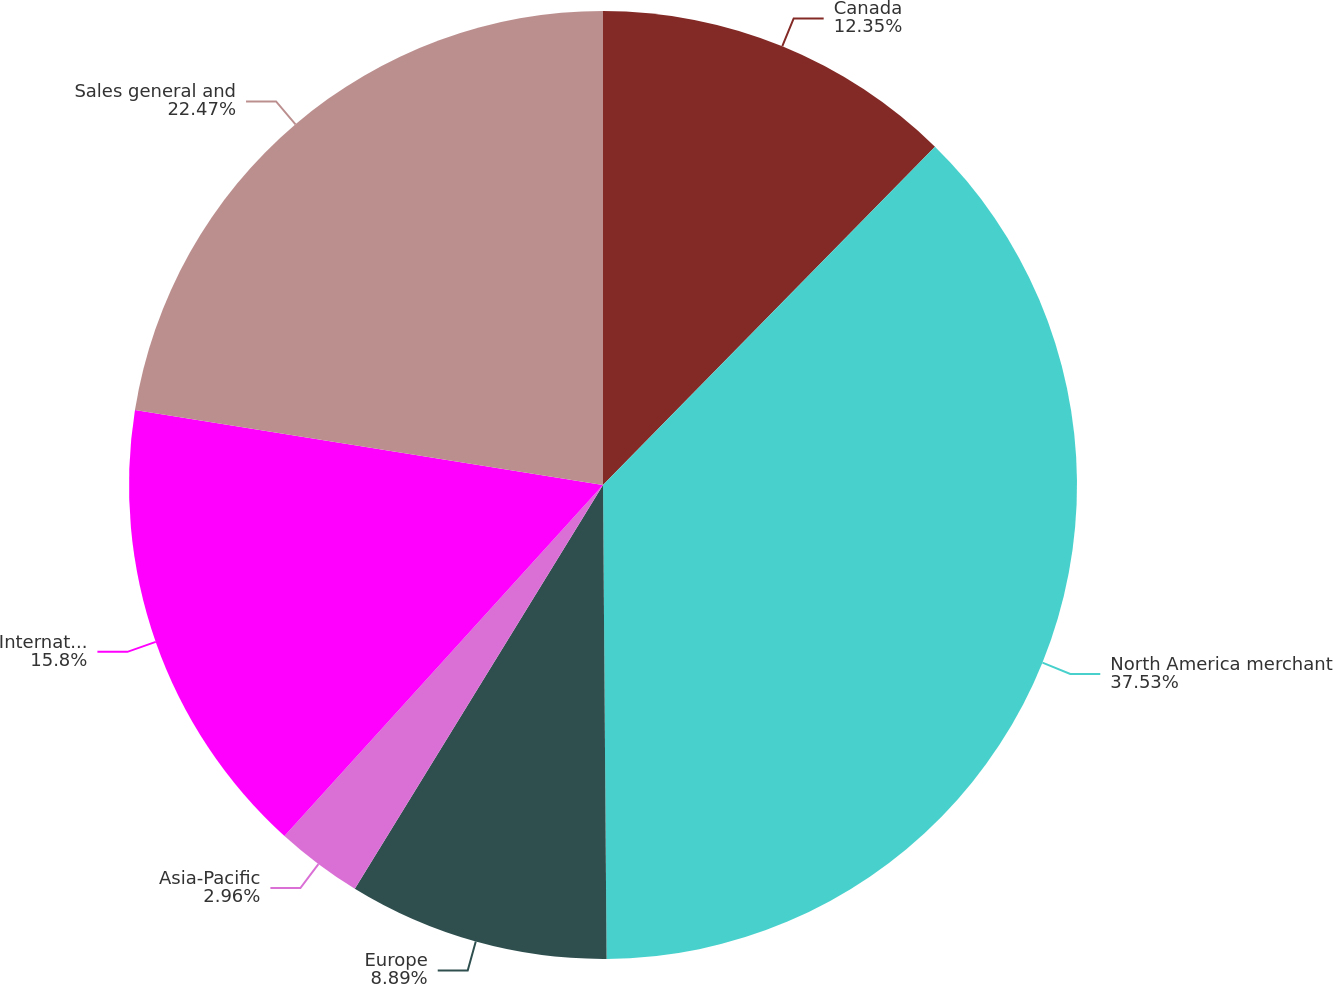Convert chart. <chart><loc_0><loc_0><loc_500><loc_500><pie_chart><fcel>Canada<fcel>North America merchant<fcel>Europe<fcel>Asia-Pacific<fcel>International merchant<fcel>Sales general and<nl><fcel>12.35%<fcel>37.53%<fcel>8.89%<fcel>2.96%<fcel>15.8%<fcel>22.47%<nl></chart> 